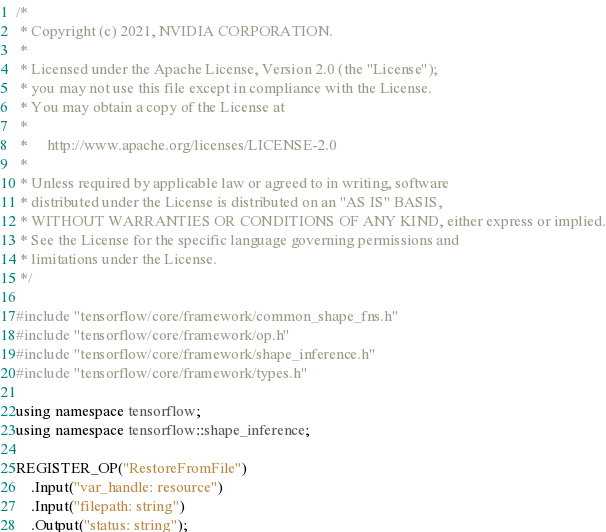<code> <loc_0><loc_0><loc_500><loc_500><_C++_>/*
 * Copyright (c) 2021, NVIDIA CORPORATION.
 *
 * Licensed under the Apache License, Version 2.0 (the "License");
 * you may not use this file except in compliance with the License.
 * You may obtain a copy of the License at
 *
 *     http://www.apache.org/licenses/LICENSE-2.0
 *
 * Unless required by applicable law or agreed to in writing, software
 * distributed under the License is distributed on an "AS IS" BASIS,
 * WITHOUT WARRANTIES OR CONDITIONS OF ANY KIND, either express or implied.
 * See the License for the specific language governing permissions and
 * limitations under the License.
 */

#include "tensorflow/core/framework/common_shape_fns.h"
#include "tensorflow/core/framework/op.h"
#include "tensorflow/core/framework/shape_inference.h"
#include "tensorflow/core/framework/types.h"

using namespace tensorflow;
using namespace tensorflow::shape_inference;

REGISTER_OP("RestoreFromFile")
    .Input("var_handle: resource")
    .Input("filepath: string")
    .Output("status: string");</code> 